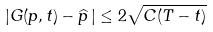<formula> <loc_0><loc_0><loc_500><loc_500>| G ( p , t ) - \widehat { p } \, | \leq 2 \sqrt { C ( T - t ) }</formula> 